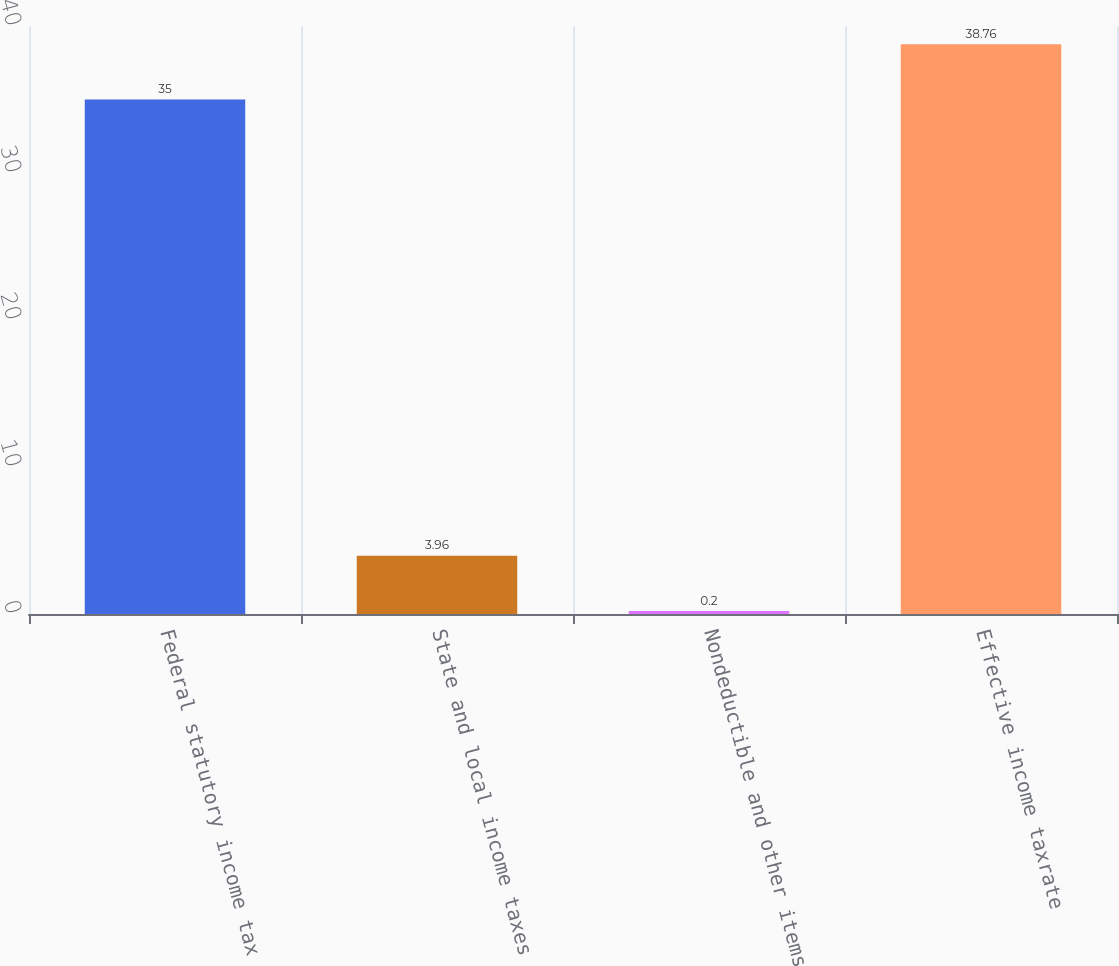Convert chart to OTSL. <chart><loc_0><loc_0><loc_500><loc_500><bar_chart><fcel>Federal statutory income tax<fcel>State and local income taxes<fcel>Nondeductible and other items<fcel>Effective income taxrate<nl><fcel>35<fcel>3.96<fcel>0.2<fcel>38.76<nl></chart> 